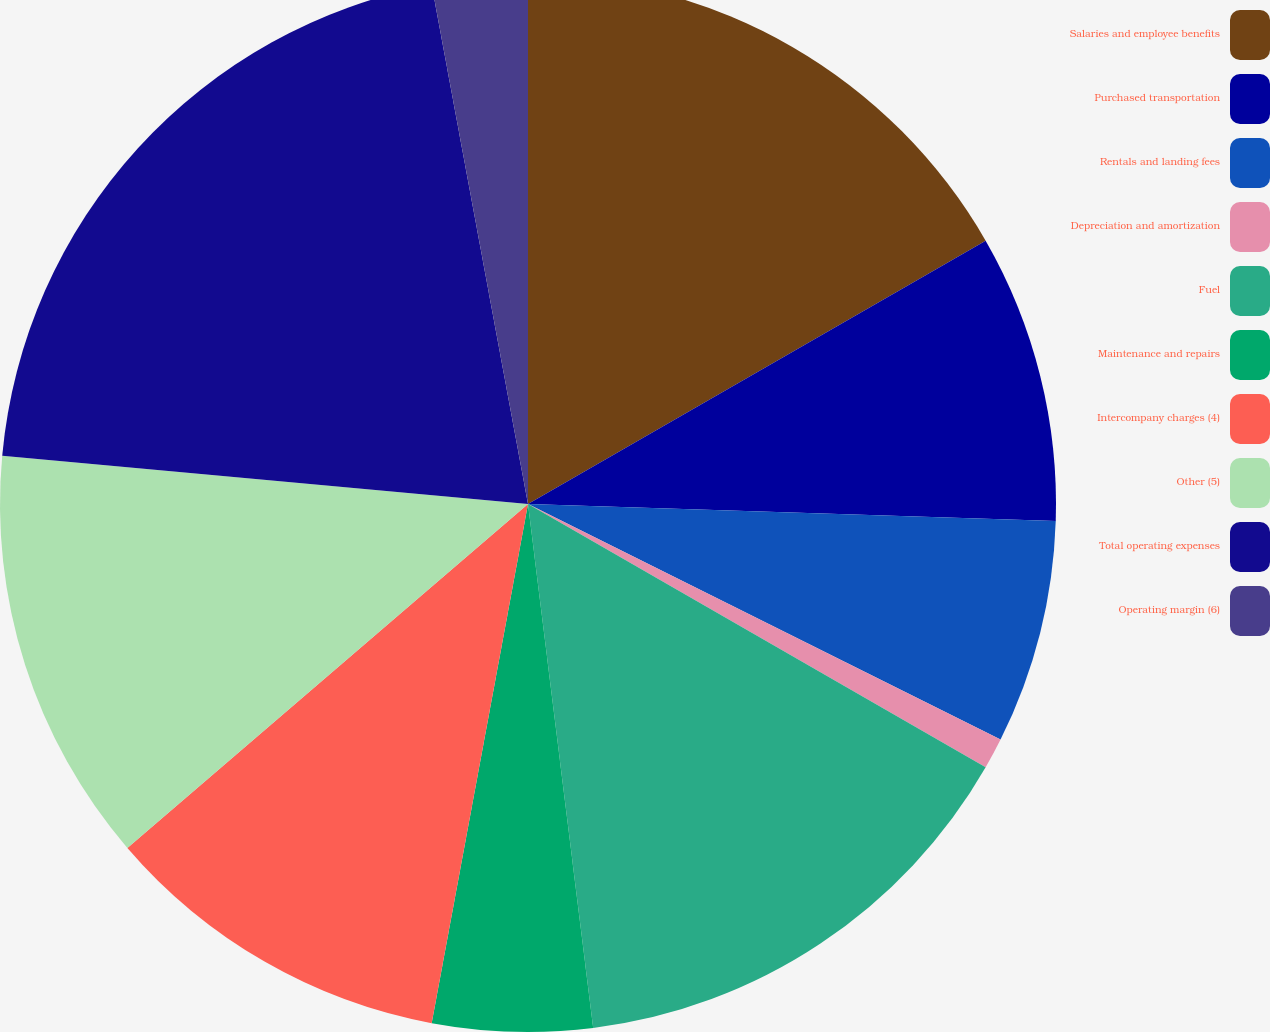<chart> <loc_0><loc_0><loc_500><loc_500><pie_chart><fcel>Salaries and employee benefits<fcel>Purchased transportation<fcel>Rentals and landing fees<fcel>Depreciation and amortization<fcel>Fuel<fcel>Maintenance and repairs<fcel>Intercompany charges (4)<fcel>Other (5)<fcel>Total operating expenses<fcel>Operating margin (6)<nl><fcel>16.69%<fcel>8.82%<fcel>6.85%<fcel>0.95%<fcel>14.72%<fcel>4.89%<fcel>10.79%<fcel>12.75%<fcel>20.62%<fcel>2.92%<nl></chart> 